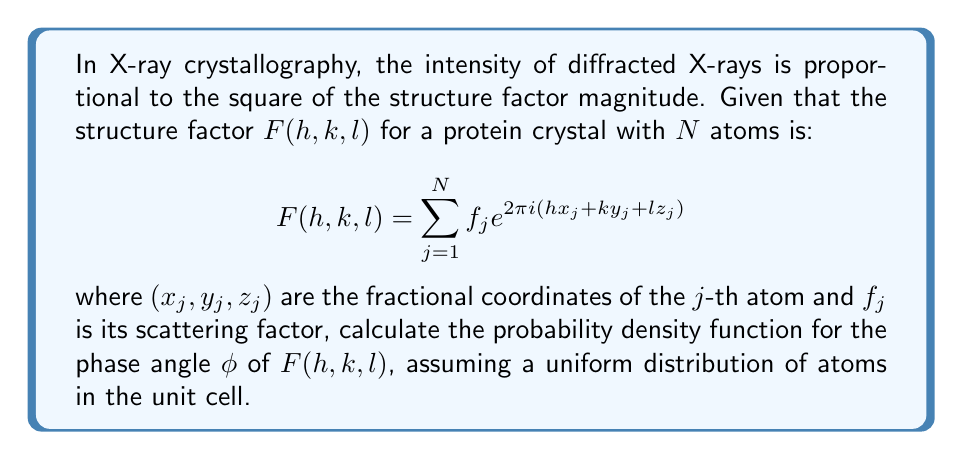Solve this math problem. To solve this problem, we'll follow these steps:

1) First, we need to understand that the structure factor $F(h,k,l)$ is a complex number. Its magnitude is related to the measured intensity, but its phase is not directly measurable, which is the core of the phase problem in crystallography.

2) For a large number of atoms $N$, we can apply the Central Limit Theorem. This theorem states that the sum of many independent random variables tends towards a normal distribution, regardless of the underlying distribution of the variables.

3) In this case, both the real and imaginary parts of $F(h,k,l)$ will be normally distributed with mean zero (assuming a uniform distribution of atoms in the unit cell).

4) Let's denote the real and imaginary parts as $A$ and $B$ respectively. Then:

   $$F(h,k,l) = A + iB$$

5) The phase angle $\phi$ is given by:

   $$\phi = \tan^{-1}(B/A)$$

6) Given that $A$ and $B$ are independent and normally distributed with mean zero and equal variances, the probability density function for $\phi$ will be uniform over the interval $[-\pi, \pi]$.

7) The probability density function for a uniform distribution over an interval $[a,b]$ is given by:

   $$p(x) = \frac{1}{b-a}$$

8) In our case, $a = -\pi$ and $b = \pi$, so the probability density function for $\phi$ is:

   $$p(\phi) = \frac{1}{2\pi}$$

This result, known as the principle of maximum entropy, is fundamental in crystallography and forms the basis for many phase retrieval methods.
Answer: $p(\phi) = \frac{1}{2\pi}$ 